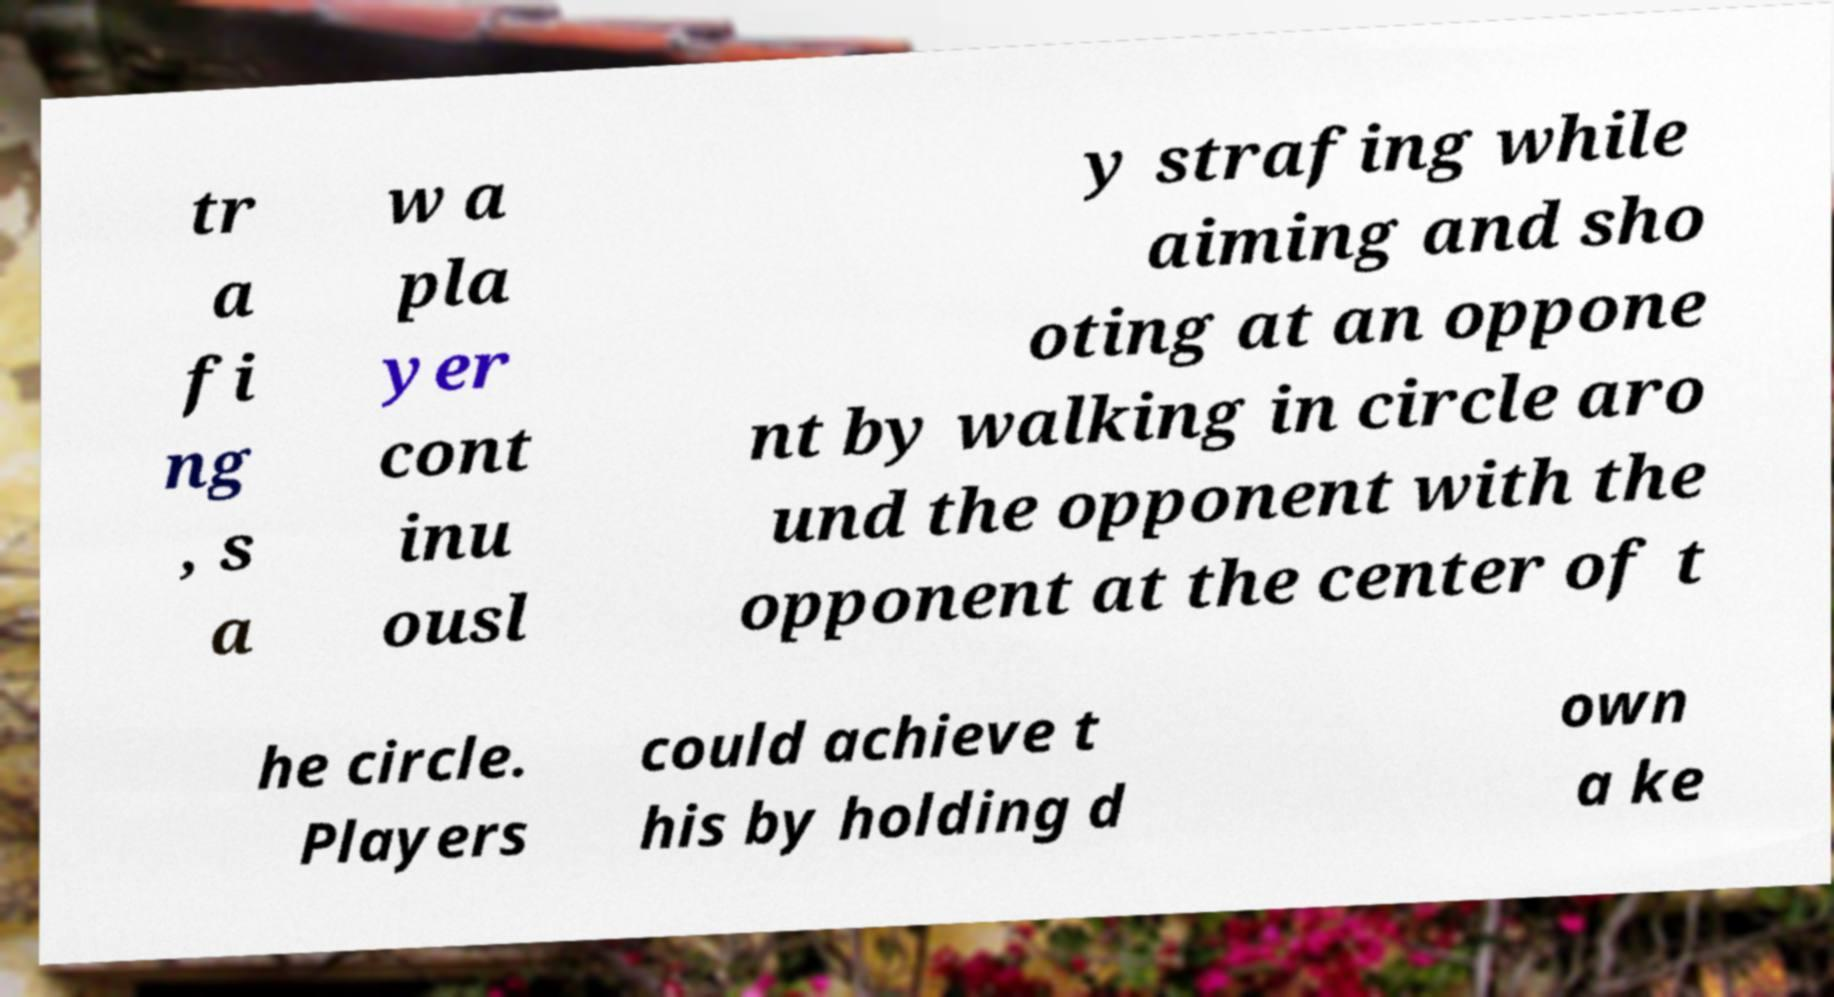Can you accurately transcribe the text from the provided image for me? tr a fi ng , s a w a pla yer cont inu ousl y strafing while aiming and sho oting at an oppone nt by walking in circle aro und the opponent with the opponent at the center of t he circle. Players could achieve t his by holding d own a ke 